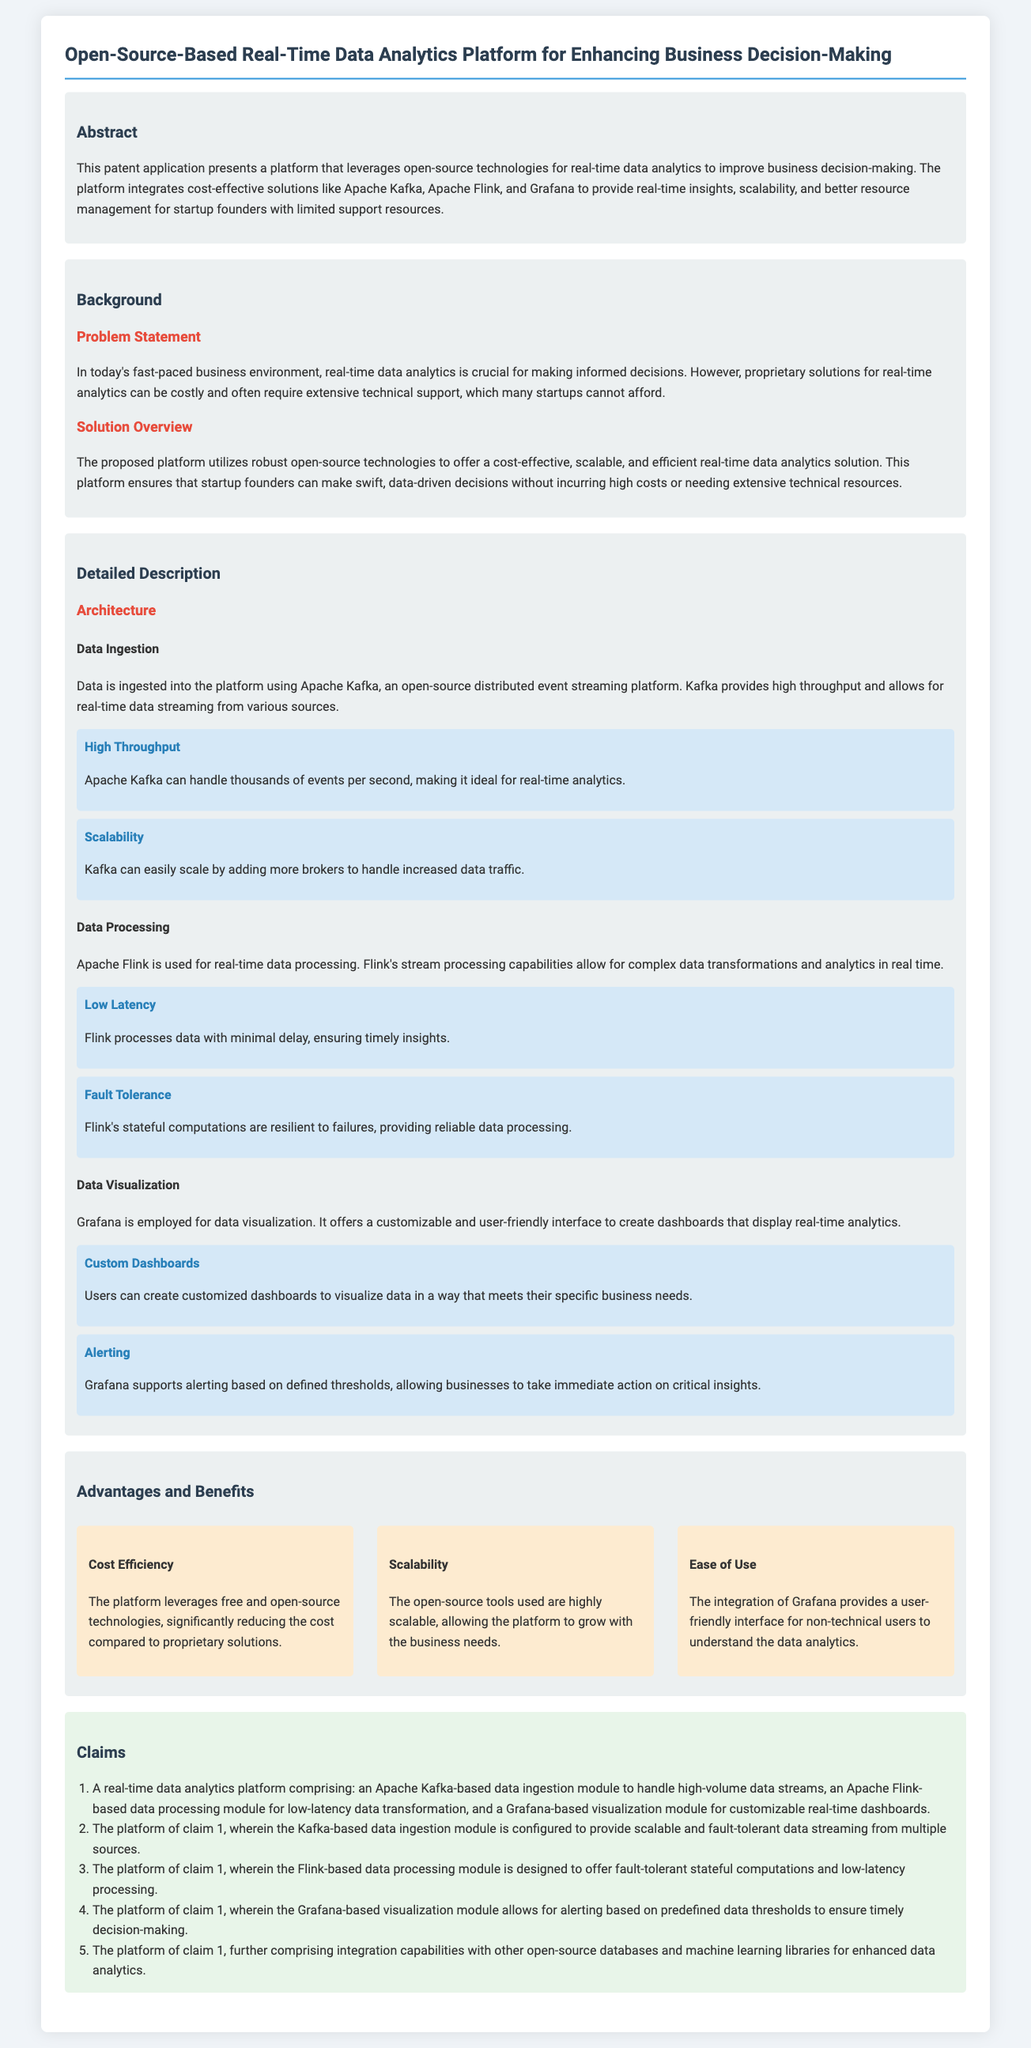What is the title of the patent application? The title of the patent application is mentioned at the top of the document.
Answer: Open-Source-Based Real-Time Data Analytics Platform for Enhancing Business Decision-Making What technologies are used for data ingestion? The specific technology for data ingestion is highlighted in the architecture section of the document.
Answer: Apache Kafka What is the primary function of Apache Flink in the platform? The function of Apache Flink is explained within the detailed description, particularly in the data processing section.
Answer: Real-time data processing What feature does Grafana provide for visualizing data? The document indicates a specific feature offered by Grafana in the data visualization section.
Answer: Custom dashboards How many claims are included in the patent application? The number of claims is provided in the claims section of the document.
Answer: Five What is one advantage of using open-source technologies mentioned in the document? The advantages section lists specific benefits of open-source technologies.
Answer: Cost Efficiency Which problem does the platform aim to solve? The problem to be solved is clearly stated in the problem statement part of the document.
Answer: Costly proprietary solutions What is a key benefit for startup founders using this platform? The document emphasizes specific benefits in the advantages and benefits section.
Answer: Better resource management 